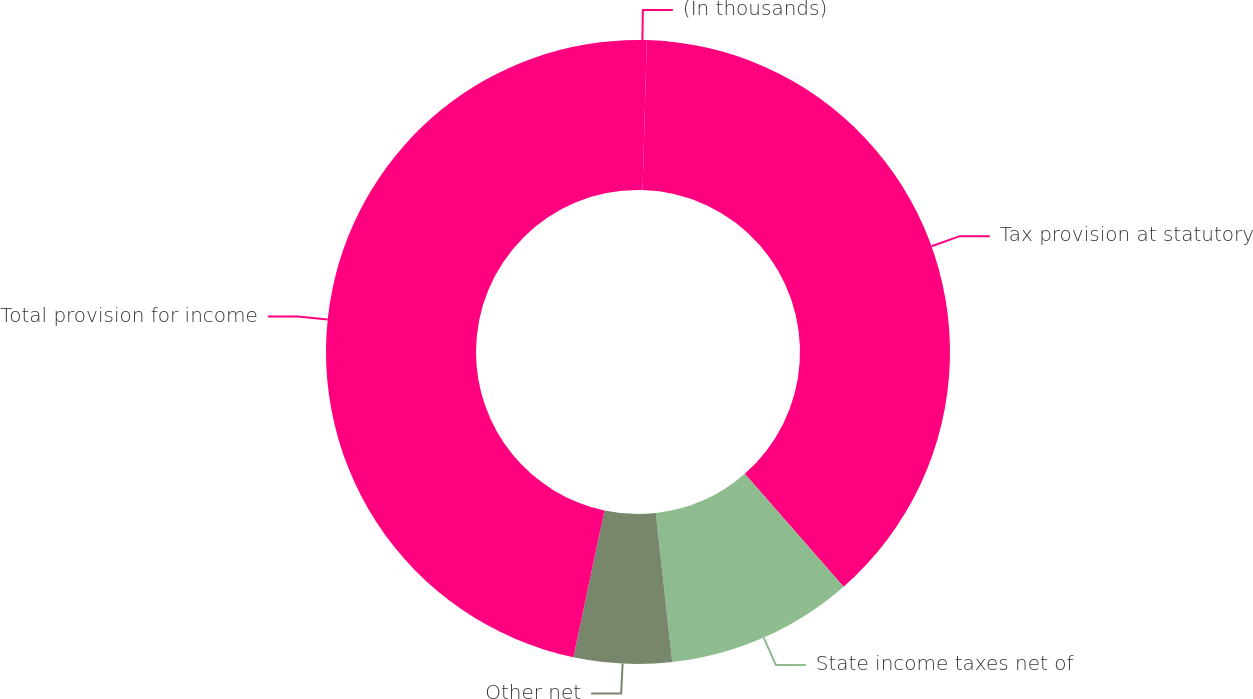<chart> <loc_0><loc_0><loc_500><loc_500><pie_chart><fcel>(In thousands)<fcel>Tax provision at statutory<fcel>State income taxes net of<fcel>Other net<fcel>Total provision for income<nl><fcel>0.45%<fcel>38.1%<fcel>9.7%<fcel>5.07%<fcel>46.68%<nl></chart> 